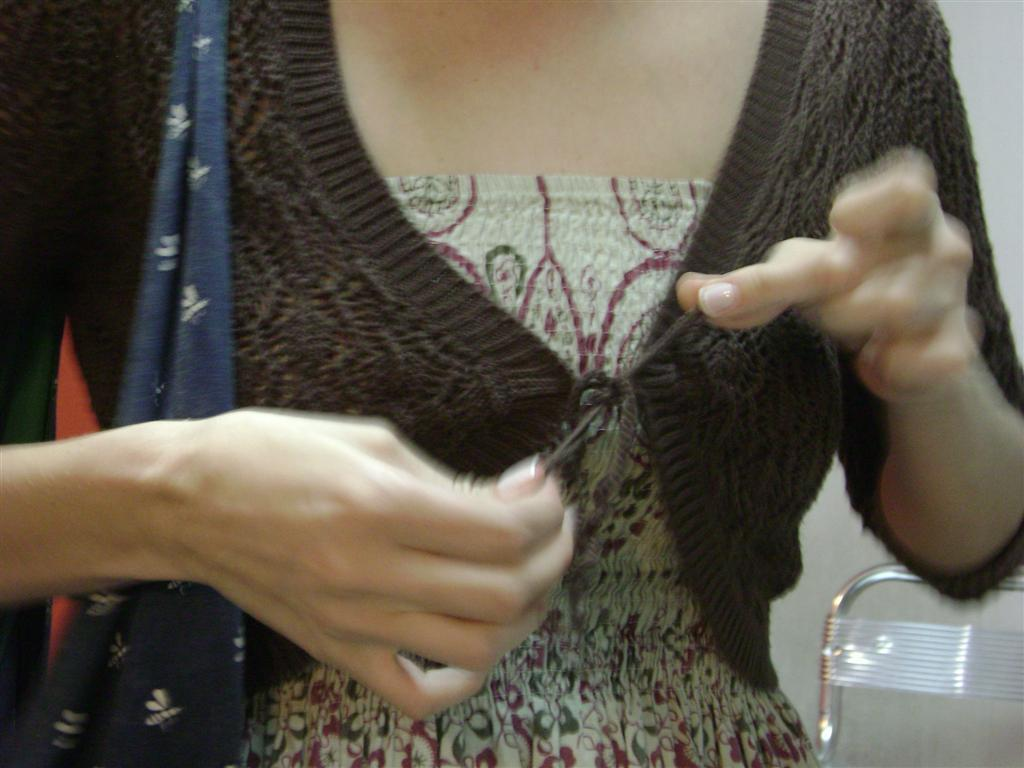Who is the main subject in the image? There is a woman in the center of the image. What is located on the right side bottom of the image? There is a chair on the right side bottom of the image. How many trucks are parked behind the woman in the image? There are no trucks visible in the image. What type of badge is the woman wearing in the image? The woman is not wearing any badge in the image. 